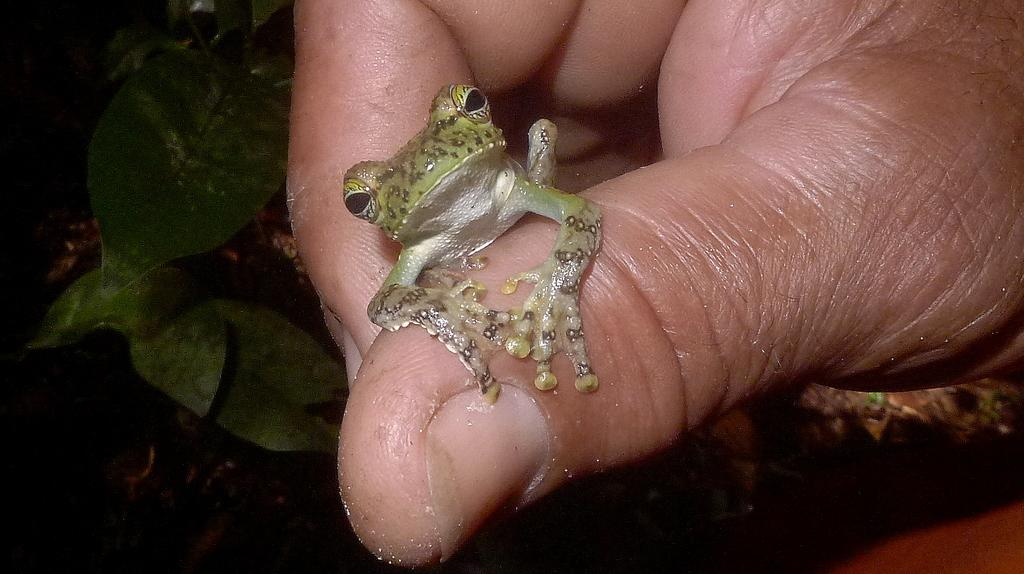What is the person's hand holding in the image? There is a person's hand holding a frog in the image. What can be seen in the background of the image? There are plants visible in the background of the image. How many girls are standing near the stream in the image? There is no stream or girls present in the image; it features a person's hand holding a frog with plants in the background. 